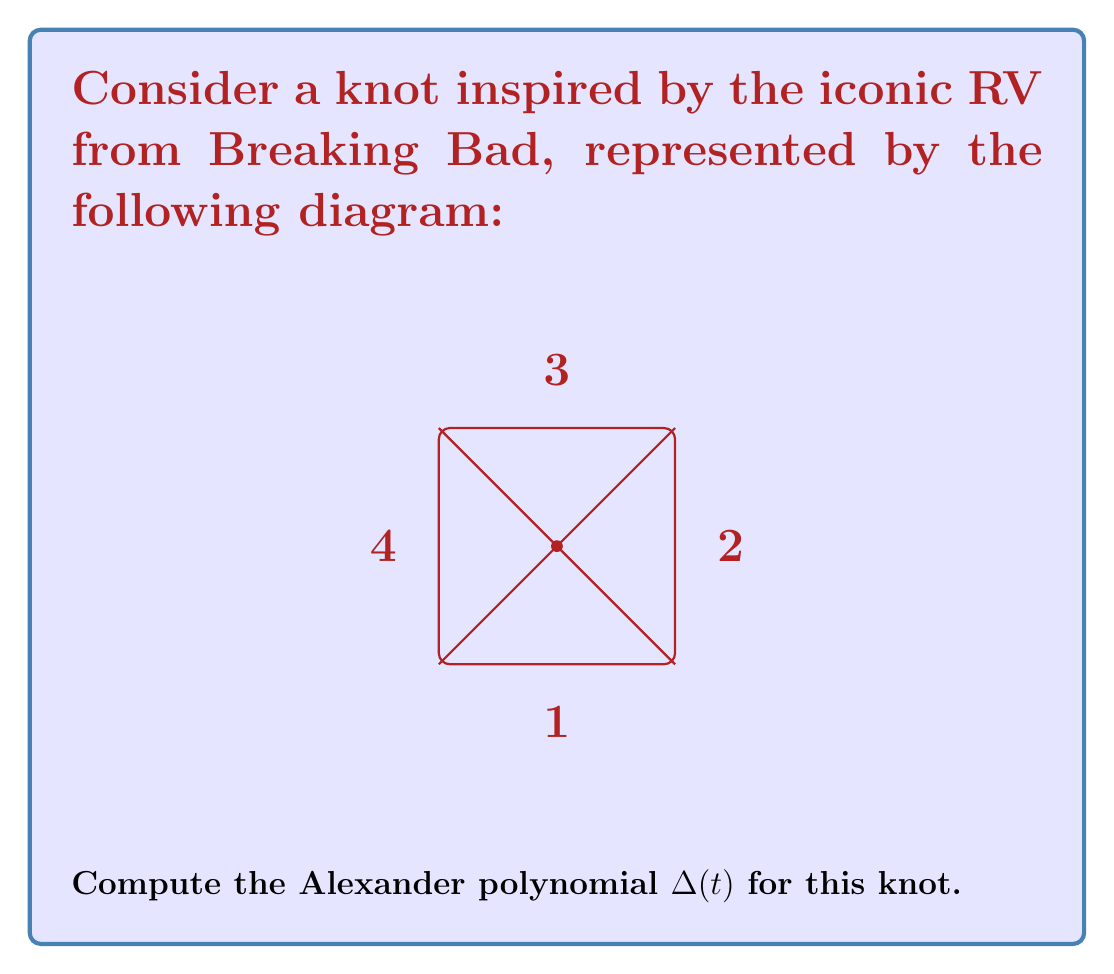Give your solution to this math problem. To compute the Alexander polynomial for this knot, we'll follow these steps:

1) First, we need to label the arcs and crossings. The diagram already has the arcs labeled 1, 2, 3, and 4. Let's label the central crossing as A.

2) Now, we create the Alexander matrix. For each crossing, we create a row in the matrix. The columns correspond to the arcs. We use the following rules:
   - For an undercrossing, we put 1-t in the column of the undercrossing arc.
   - For the two overcrossing arcs, we put -1 in the column of the arc that's on the right when facing the direction of the undercrossing, and t in the column of the arc on the left.

3) Our matrix will be:

   $$
   \begin{pmatrix}
   1-t & -1 & t & 0 \\
   0 & 1-t & -1 & t \\
   t & 0 & 1-t & -1 \\
   -1 & t & 0 & 1-t
   \end{pmatrix}
   $$

4) To find the Alexander polynomial, we need to calculate the determinant of any 3x3 minor of this matrix and divide by $(1-t)$.

5) Let's choose the minor formed by deleting the first row and first column:

   $$
   \begin{vmatrix}
   1-t & -1 & t \\
   0 & 1-t & -1 \\
   t & 0 & 1-t
   \end{vmatrix}
   $$

6) Calculating this determinant:
   $$(1-t)((1-t)(1-t) - 0) - (-1)(0 - t(-1)) + t(0 - 0)$$
   $$= (1-t)((1-t)^2) + t$$
   $$= (1-t)^3 + t$$

7) Dividing by $(1-t)$:
   $$\frac{(1-t)^3 + t}{1-t} = (1-t)^2 + \frac{t}{1-t}$$

8) Simplifying:
   $$(1-2t+t^2) + \frac{t}{1-t} = 1-2t+t^2 + \frac{t}{1-t}$$

This is our Alexander polynomial.
Answer: $\Delta(t) = 1-2t+t^2 + \frac{t}{1-t}$ 